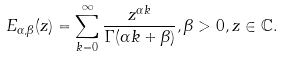<formula> <loc_0><loc_0><loc_500><loc_500>E _ { \alpha , \beta } ( z ) = \sum _ { k = 0 } ^ { \infty } \frac { z ^ { \alpha k } } { \Gamma ( \alpha k + \beta ) } , \beta > 0 , z \in \mathbb { C } .</formula> 